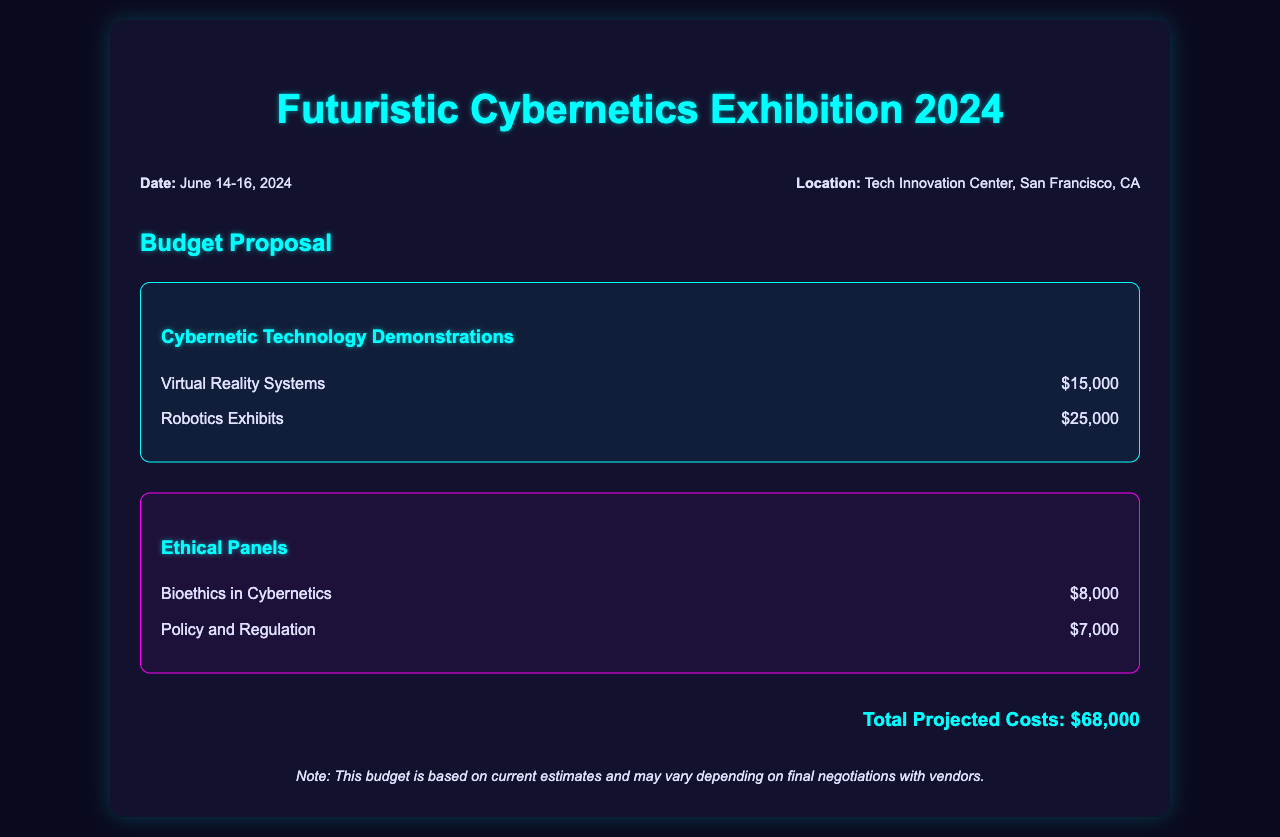what is the date of the exhibition? The date of the exhibition is specified in the document as June 14-16, 2024.
Answer: June 14-16, 2024 where is the exhibition taking place? The location of the exhibition is mentioned in the document, which is the Tech Innovation Center, San Francisco, CA.
Answer: Tech Innovation Center, San Francisco, CA how much is allocated for Virtual Reality Systems? The allocated cost for Virtual Reality Systems is directly stated in the document as $15,000.
Answer: $15,000 what is the total projected cost for the exhibition? The total projected costs are summarized in the document, which adds up to $68,000.
Answer: $68,000 how much does the "Policy and Regulation" panel cost? The cost for the "Policy and Regulation" ethical panel is provided in the document as $7,000.
Answer: $7,000 what is one of the topics for the ethical panels? The document lists multiple topics for the ethical panels, one of which is "Bioethics in Cybernetics."
Answer: Bioethics in Cybernetics which type of costs does the document outline? The document outlines costs related to Cybernetic Technology Demonstrations and Ethical Panels.
Answer: Cybernetic Technology Demonstrations and Ethical Panels what is the purpose of the document? The purpose of the document is to provide a budget proposal for the Futuristic Cybernetics Exhibition 2024.
Answer: Budget proposal for the Futuristic Cybernetics Exhibition 2024 